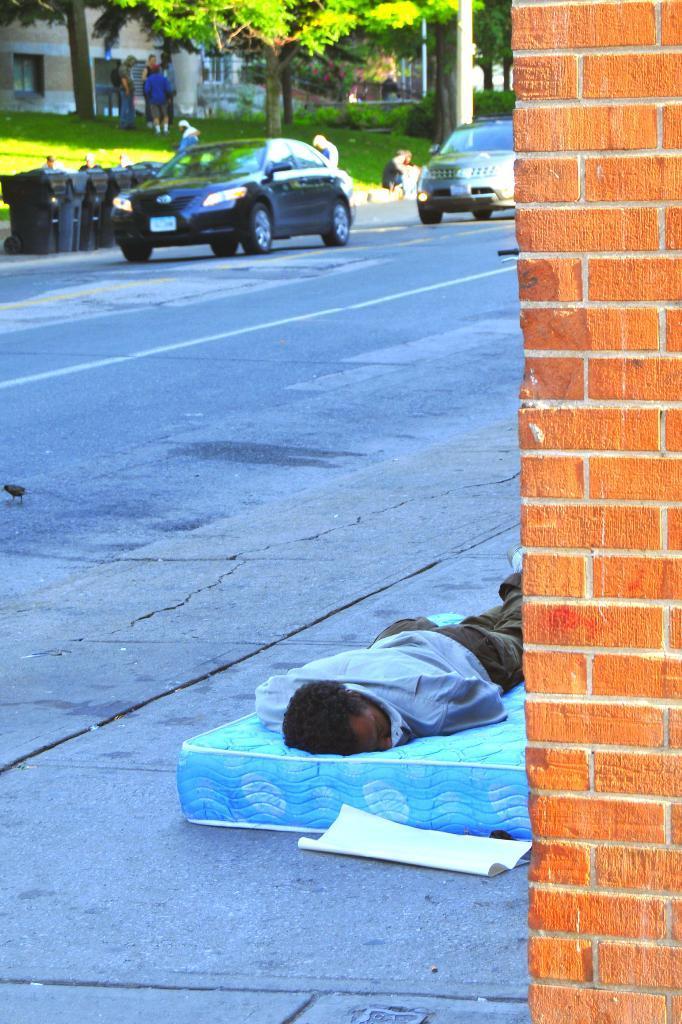Please provide a concise description of this image. This is an outside view. On the right side there is a wall. Beside the wall a man is sleeping on a bed which is placed on the footpath. In the background there are two cars on the road. Beside the road few dustbins are placed. At the top, I can see few people are standing on the ground. There are many trees, plants and buildings. 